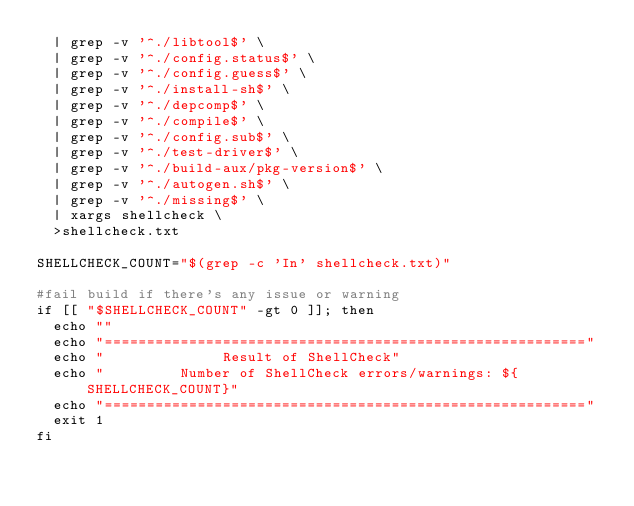Convert code to text. <code><loc_0><loc_0><loc_500><loc_500><_Bash_>  | grep -v '^./libtool$' \
  | grep -v '^./config.status$' \
  | grep -v '^./config.guess$' \
  | grep -v '^./install-sh$' \
  | grep -v '^./depcomp$' \
  | grep -v '^./compile$' \
  | grep -v '^./config.sub$' \
  | grep -v '^./test-driver$' \
  | grep -v '^./build-aux/pkg-version$' \
  | grep -v '^./autogen.sh$' \
  | grep -v '^./missing$' \
  | xargs shellcheck \
  >shellcheck.txt

SHELLCHECK_COUNT="$(grep -c 'In' shellcheck.txt)"

#fail build if there's any issue or warning
if [[ "$SHELLCHECK_COUNT" -gt 0 ]]; then
  echo ""
  echo "========================================================="
  echo "              Result of ShellCheck"
  echo "         Number of ShellCheck errors/warnings: ${SHELLCHECK_COUNT}"
  echo "========================================================="
  exit 1
fi
</code> 